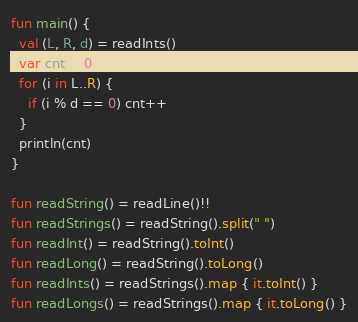Convert code to text. <code><loc_0><loc_0><loc_500><loc_500><_Kotlin_>fun main() {
  val (L, R, d) = readInts()
  var cnt = 0
  for (i in L..R) {
    if (i % d == 0) cnt++
  }
  println(cnt)
}

fun readString() = readLine()!!
fun readStrings() = readString().split(" ")
fun readInt() = readString().toInt()
fun readLong() = readString().toLong()
fun readInts() = readStrings().map { it.toInt() }
fun readLongs() = readStrings().map { it.toLong() }
</code> 